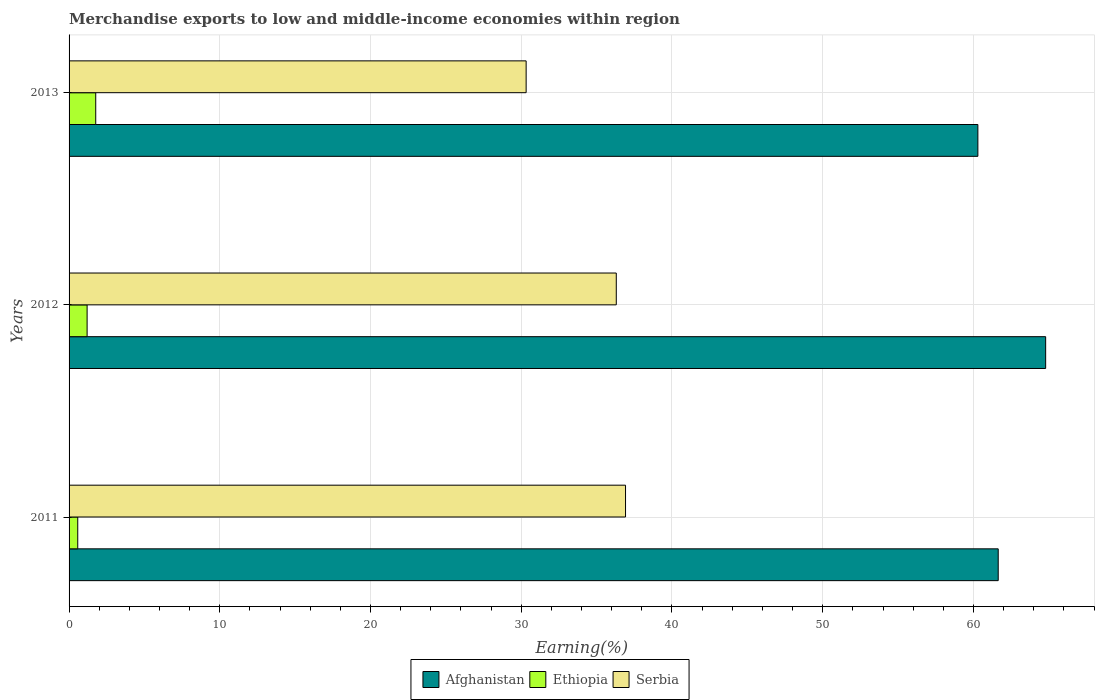How many different coloured bars are there?
Keep it short and to the point. 3. Are the number of bars per tick equal to the number of legend labels?
Your answer should be compact. Yes. Are the number of bars on each tick of the Y-axis equal?
Offer a terse response. Yes. What is the label of the 2nd group of bars from the top?
Give a very brief answer. 2012. What is the percentage of amount earned from merchandise exports in Ethiopia in 2012?
Give a very brief answer. 1.2. Across all years, what is the maximum percentage of amount earned from merchandise exports in Ethiopia?
Offer a very short reply. 1.77. Across all years, what is the minimum percentage of amount earned from merchandise exports in Serbia?
Offer a terse response. 30.32. In which year was the percentage of amount earned from merchandise exports in Ethiopia minimum?
Offer a terse response. 2011. What is the total percentage of amount earned from merchandise exports in Afghanistan in the graph?
Provide a succinct answer. 186.73. What is the difference between the percentage of amount earned from merchandise exports in Afghanistan in 2011 and that in 2013?
Provide a succinct answer. 1.35. What is the difference between the percentage of amount earned from merchandise exports in Ethiopia in 2013 and the percentage of amount earned from merchandise exports in Serbia in 2012?
Keep it short and to the point. -34.54. What is the average percentage of amount earned from merchandise exports in Ethiopia per year?
Provide a succinct answer. 1.18. In the year 2011, what is the difference between the percentage of amount earned from merchandise exports in Serbia and percentage of amount earned from merchandise exports in Afghanistan?
Ensure brevity in your answer.  -24.73. In how many years, is the percentage of amount earned from merchandise exports in Ethiopia greater than 40 %?
Provide a succinct answer. 0. What is the ratio of the percentage of amount earned from merchandise exports in Afghanistan in 2011 to that in 2013?
Give a very brief answer. 1.02. Is the percentage of amount earned from merchandise exports in Afghanistan in 2012 less than that in 2013?
Offer a terse response. No. What is the difference between the highest and the second highest percentage of amount earned from merchandise exports in Afghanistan?
Your answer should be very brief. 3.15. What is the difference between the highest and the lowest percentage of amount earned from merchandise exports in Serbia?
Offer a very short reply. 6.59. In how many years, is the percentage of amount earned from merchandise exports in Serbia greater than the average percentage of amount earned from merchandise exports in Serbia taken over all years?
Offer a very short reply. 2. What does the 1st bar from the top in 2013 represents?
Provide a short and direct response. Serbia. What does the 2nd bar from the bottom in 2011 represents?
Your answer should be compact. Ethiopia. Is it the case that in every year, the sum of the percentage of amount earned from merchandise exports in Ethiopia and percentage of amount earned from merchandise exports in Serbia is greater than the percentage of amount earned from merchandise exports in Afghanistan?
Your answer should be very brief. No. Are all the bars in the graph horizontal?
Ensure brevity in your answer.  Yes. What is the difference between two consecutive major ticks on the X-axis?
Provide a short and direct response. 10. How are the legend labels stacked?
Your answer should be compact. Horizontal. What is the title of the graph?
Your answer should be very brief. Merchandise exports to low and middle-income economies within region. What is the label or title of the X-axis?
Your response must be concise. Earning(%). What is the label or title of the Y-axis?
Offer a very short reply. Years. What is the Earning(%) of Afghanistan in 2011?
Ensure brevity in your answer.  61.64. What is the Earning(%) in Ethiopia in 2011?
Offer a terse response. 0.58. What is the Earning(%) in Serbia in 2011?
Give a very brief answer. 36.92. What is the Earning(%) of Afghanistan in 2012?
Give a very brief answer. 64.79. What is the Earning(%) of Ethiopia in 2012?
Offer a very short reply. 1.2. What is the Earning(%) of Serbia in 2012?
Make the answer very short. 36.3. What is the Earning(%) of Afghanistan in 2013?
Offer a terse response. 60.29. What is the Earning(%) in Ethiopia in 2013?
Keep it short and to the point. 1.77. What is the Earning(%) of Serbia in 2013?
Offer a very short reply. 30.32. Across all years, what is the maximum Earning(%) in Afghanistan?
Your answer should be very brief. 64.79. Across all years, what is the maximum Earning(%) in Ethiopia?
Your answer should be compact. 1.77. Across all years, what is the maximum Earning(%) in Serbia?
Offer a very short reply. 36.92. Across all years, what is the minimum Earning(%) of Afghanistan?
Give a very brief answer. 60.29. Across all years, what is the minimum Earning(%) in Ethiopia?
Your answer should be compact. 0.58. Across all years, what is the minimum Earning(%) of Serbia?
Keep it short and to the point. 30.32. What is the total Earning(%) of Afghanistan in the graph?
Offer a very short reply. 186.73. What is the total Earning(%) of Ethiopia in the graph?
Keep it short and to the point. 3.54. What is the total Earning(%) in Serbia in the graph?
Offer a terse response. 103.55. What is the difference between the Earning(%) in Afghanistan in 2011 and that in 2012?
Your answer should be very brief. -3.15. What is the difference between the Earning(%) of Ethiopia in 2011 and that in 2012?
Keep it short and to the point. -0.62. What is the difference between the Earning(%) of Serbia in 2011 and that in 2012?
Provide a succinct answer. 0.61. What is the difference between the Earning(%) in Afghanistan in 2011 and that in 2013?
Make the answer very short. 1.35. What is the difference between the Earning(%) of Ethiopia in 2011 and that in 2013?
Keep it short and to the point. -1.19. What is the difference between the Earning(%) in Serbia in 2011 and that in 2013?
Your answer should be very brief. 6.59. What is the difference between the Earning(%) of Afghanistan in 2012 and that in 2013?
Ensure brevity in your answer.  4.5. What is the difference between the Earning(%) in Ethiopia in 2012 and that in 2013?
Keep it short and to the point. -0.57. What is the difference between the Earning(%) in Serbia in 2012 and that in 2013?
Make the answer very short. 5.98. What is the difference between the Earning(%) of Afghanistan in 2011 and the Earning(%) of Ethiopia in 2012?
Keep it short and to the point. 60.45. What is the difference between the Earning(%) of Afghanistan in 2011 and the Earning(%) of Serbia in 2012?
Your response must be concise. 25.34. What is the difference between the Earning(%) of Ethiopia in 2011 and the Earning(%) of Serbia in 2012?
Give a very brief answer. -35.73. What is the difference between the Earning(%) in Afghanistan in 2011 and the Earning(%) in Ethiopia in 2013?
Make the answer very short. 59.87. What is the difference between the Earning(%) of Afghanistan in 2011 and the Earning(%) of Serbia in 2013?
Your response must be concise. 31.32. What is the difference between the Earning(%) of Ethiopia in 2011 and the Earning(%) of Serbia in 2013?
Provide a succinct answer. -29.75. What is the difference between the Earning(%) of Afghanistan in 2012 and the Earning(%) of Ethiopia in 2013?
Offer a terse response. 63.02. What is the difference between the Earning(%) of Afghanistan in 2012 and the Earning(%) of Serbia in 2013?
Provide a short and direct response. 34.47. What is the difference between the Earning(%) in Ethiopia in 2012 and the Earning(%) in Serbia in 2013?
Give a very brief answer. -29.13. What is the average Earning(%) of Afghanistan per year?
Offer a terse response. 62.24. What is the average Earning(%) of Ethiopia per year?
Keep it short and to the point. 1.18. What is the average Earning(%) in Serbia per year?
Your answer should be compact. 34.52. In the year 2011, what is the difference between the Earning(%) of Afghanistan and Earning(%) of Ethiopia?
Your response must be concise. 61.07. In the year 2011, what is the difference between the Earning(%) of Afghanistan and Earning(%) of Serbia?
Your answer should be compact. 24.73. In the year 2011, what is the difference between the Earning(%) of Ethiopia and Earning(%) of Serbia?
Make the answer very short. -36.34. In the year 2012, what is the difference between the Earning(%) in Afghanistan and Earning(%) in Ethiopia?
Your response must be concise. 63.59. In the year 2012, what is the difference between the Earning(%) of Afghanistan and Earning(%) of Serbia?
Give a very brief answer. 28.49. In the year 2012, what is the difference between the Earning(%) in Ethiopia and Earning(%) in Serbia?
Offer a terse response. -35.11. In the year 2013, what is the difference between the Earning(%) in Afghanistan and Earning(%) in Ethiopia?
Your answer should be very brief. 58.52. In the year 2013, what is the difference between the Earning(%) in Afghanistan and Earning(%) in Serbia?
Give a very brief answer. 29.97. In the year 2013, what is the difference between the Earning(%) in Ethiopia and Earning(%) in Serbia?
Make the answer very short. -28.56. What is the ratio of the Earning(%) in Afghanistan in 2011 to that in 2012?
Give a very brief answer. 0.95. What is the ratio of the Earning(%) in Ethiopia in 2011 to that in 2012?
Offer a very short reply. 0.48. What is the ratio of the Earning(%) in Serbia in 2011 to that in 2012?
Offer a very short reply. 1.02. What is the ratio of the Earning(%) in Afghanistan in 2011 to that in 2013?
Provide a short and direct response. 1.02. What is the ratio of the Earning(%) of Ethiopia in 2011 to that in 2013?
Give a very brief answer. 0.33. What is the ratio of the Earning(%) in Serbia in 2011 to that in 2013?
Your answer should be compact. 1.22. What is the ratio of the Earning(%) in Afghanistan in 2012 to that in 2013?
Give a very brief answer. 1.07. What is the ratio of the Earning(%) of Ethiopia in 2012 to that in 2013?
Provide a succinct answer. 0.68. What is the ratio of the Earning(%) in Serbia in 2012 to that in 2013?
Give a very brief answer. 1.2. What is the difference between the highest and the second highest Earning(%) of Afghanistan?
Provide a succinct answer. 3.15. What is the difference between the highest and the second highest Earning(%) of Ethiopia?
Keep it short and to the point. 0.57. What is the difference between the highest and the second highest Earning(%) in Serbia?
Make the answer very short. 0.61. What is the difference between the highest and the lowest Earning(%) of Afghanistan?
Ensure brevity in your answer.  4.5. What is the difference between the highest and the lowest Earning(%) in Ethiopia?
Your answer should be compact. 1.19. What is the difference between the highest and the lowest Earning(%) of Serbia?
Offer a terse response. 6.59. 